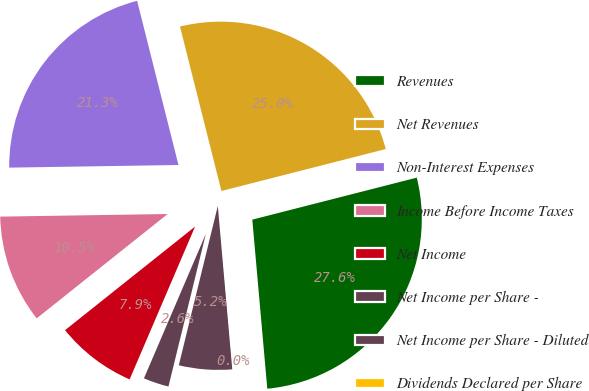Convert chart to OTSL. <chart><loc_0><loc_0><loc_500><loc_500><pie_chart><fcel>Revenues<fcel>Net Revenues<fcel>Non-Interest Expenses<fcel>Income Before Income Taxes<fcel>Net Income<fcel>Net Income per Share -<fcel>Net Income per Share - Diluted<fcel>Dividends Declared per Share<nl><fcel>27.57%<fcel>24.95%<fcel>21.32%<fcel>10.46%<fcel>7.85%<fcel>2.62%<fcel>5.23%<fcel>0.0%<nl></chart> 